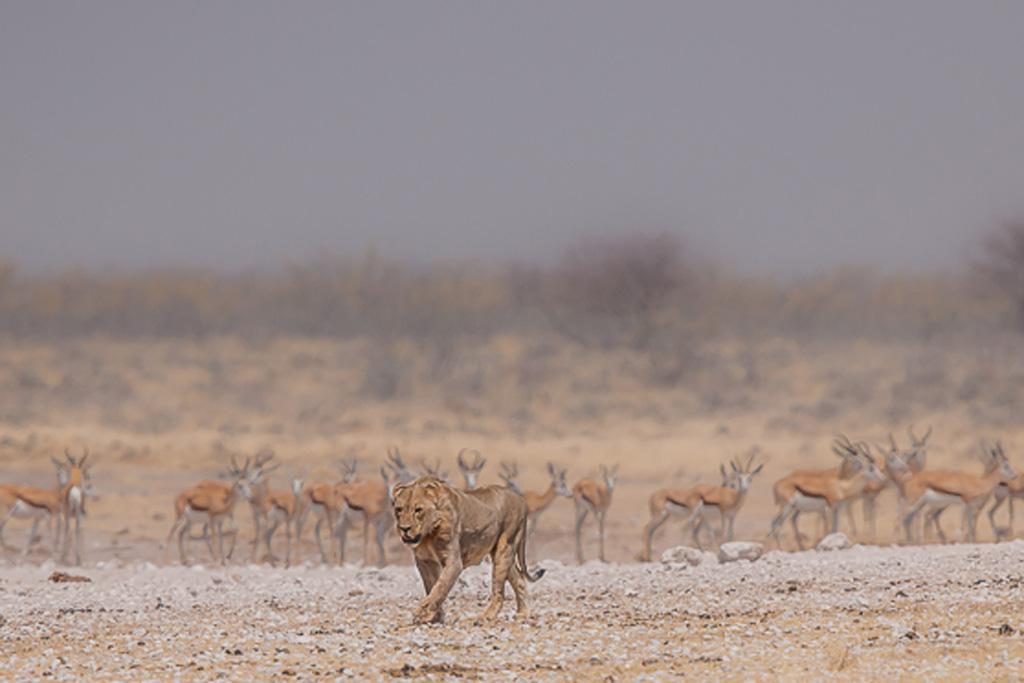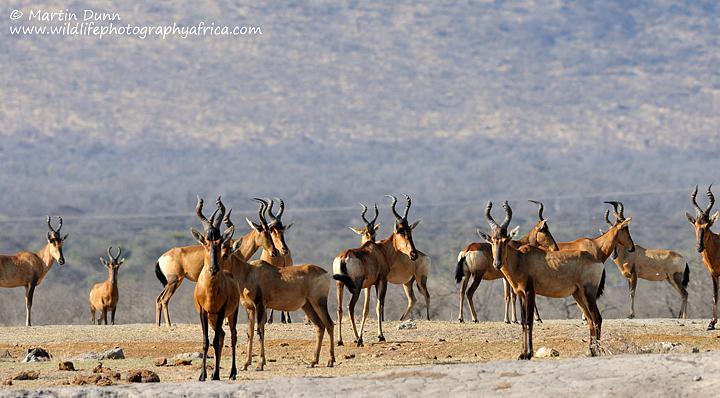The first image is the image on the left, the second image is the image on the right. Analyze the images presented: Is the assertion "Zebra are present with horned animals in one image." valid? Answer yes or no. No. 